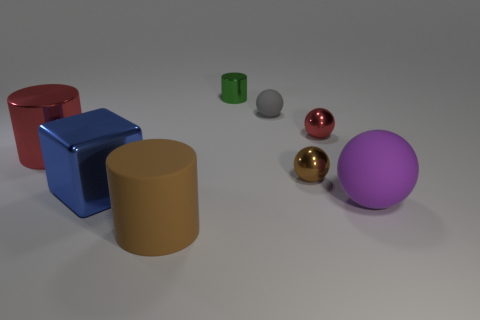Subtract all small spheres. How many spheres are left? 1 Subtract all red spheres. How many spheres are left? 3 Subtract 2 balls. How many balls are left? 2 Add 1 small red rubber cylinders. How many objects exist? 9 Subtract all blue balls. Subtract all red cubes. How many balls are left? 4 Subtract all blocks. How many objects are left? 7 Subtract 1 brown spheres. How many objects are left? 7 Subtract all large brown metal objects. Subtract all green cylinders. How many objects are left? 7 Add 6 red cylinders. How many red cylinders are left? 7 Add 8 cyan metal balls. How many cyan metal balls exist? 8 